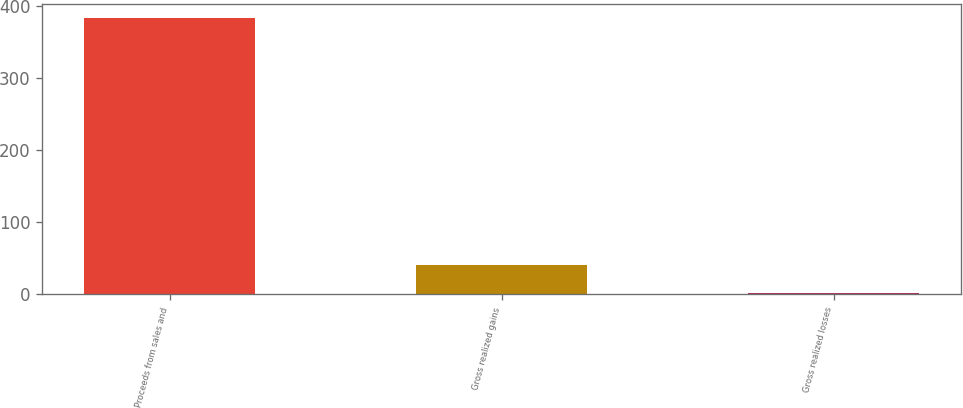Convert chart to OTSL. <chart><loc_0><loc_0><loc_500><loc_500><bar_chart><fcel>Proceeds from sales and<fcel>Gross realized gains<fcel>Gross realized losses<nl><fcel>384<fcel>40.2<fcel>2<nl></chart> 